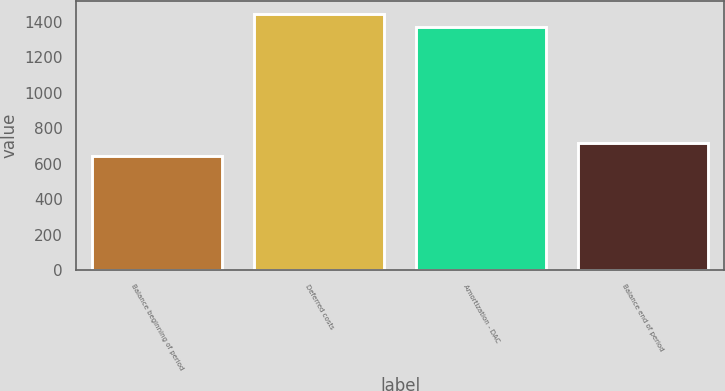<chart> <loc_0><loc_0><loc_500><loc_500><bar_chart><fcel>Balance beginning of period<fcel>Deferred costs<fcel>Amortization - DAC<fcel>Balance end of period<nl><fcel>645<fcel>1445.2<fcel>1372<fcel>718.2<nl></chart> 